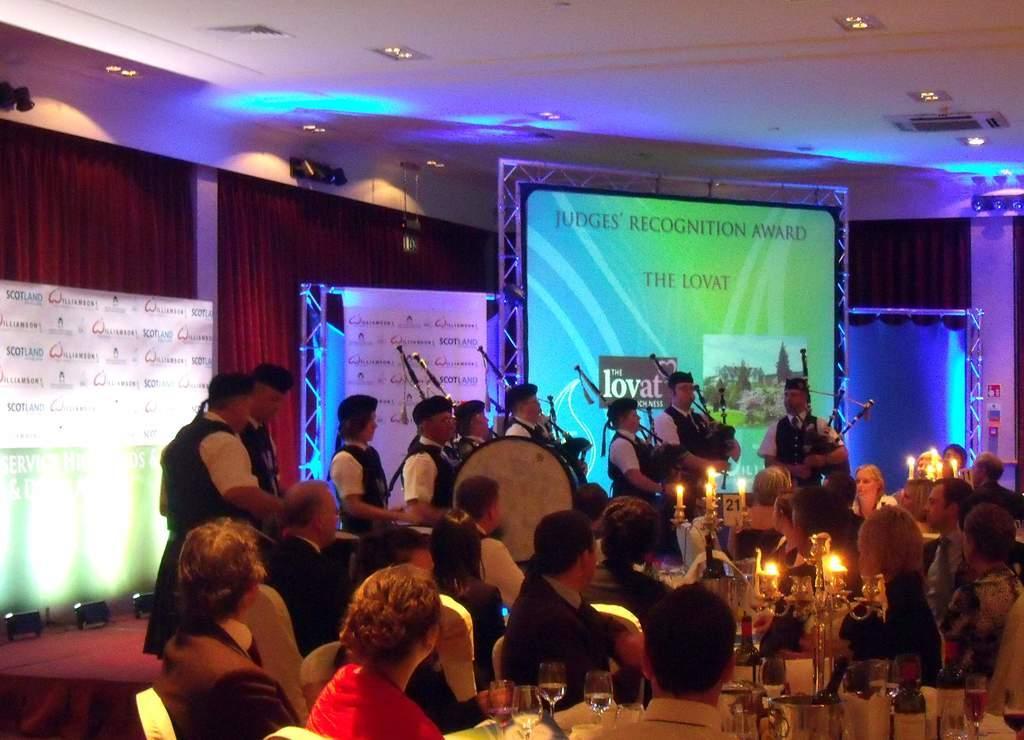How would you summarize this image in a sentence or two? In this image we have a group of people playing some instruments and beating drums and some group of people sitting in chairs near the table and their is a candle stand and in back ground we have screen, curtains and hoardings. 